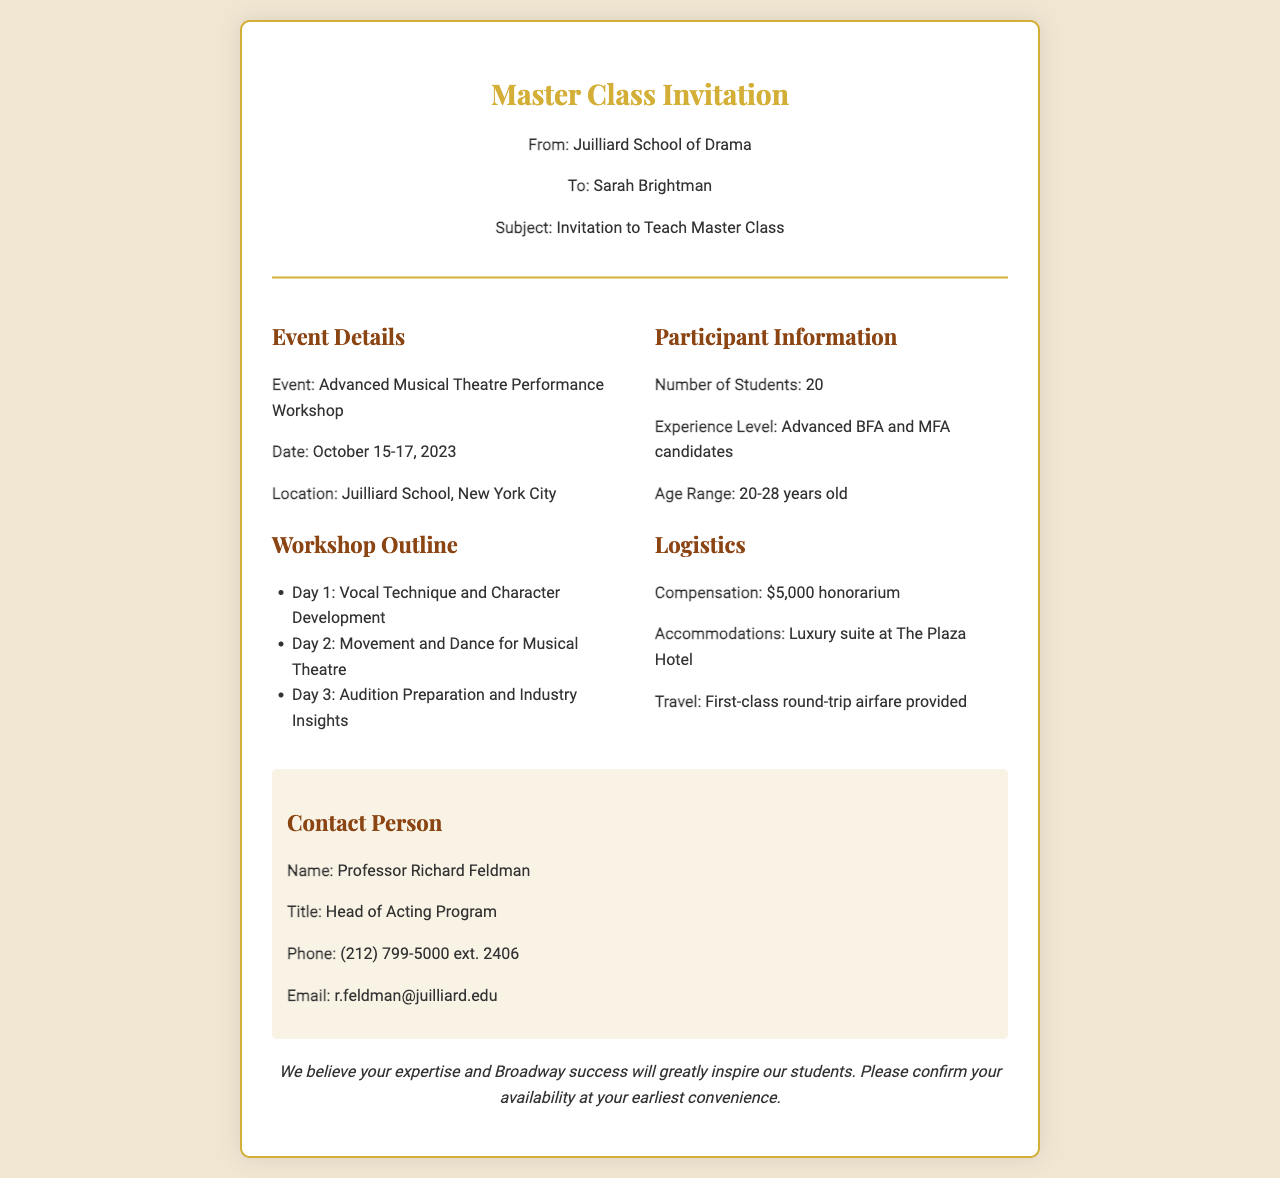What is the name of the workshop? The name of the workshop is stated in the event details section of the document.
Answer: Advanced Musical Theatre Performance Workshop What are the dates of the master class? The dates are specified under the event details, showing when the workshop will take place.
Answer: October 15-17, 2023 How many students will participate? The number of students is indicated in the participant information section.
Answer: 20 Who is the contact person for the master class? The contact person is mentioned in the contact info section, identifying who to reach for more details.
Answer: Professor Richard Feldman What is the compensation amount mentioned for teaching? The compensation is outlined in the logistics section of the document.
Answer: $5,000 honorarium What type of accommodations are provided? The specific type of accommodations is listed under the logistics heading.
Answer: Luxury suite at The Plaza Hotel Which day focuses on Movement and Dance for Musical Theatre? The workshop outline clearly states each day's focus, allowing for reasoning about which topic matches.
Answer: Day 2 What is the age range of the participants? The age range is detailed in the participant information section, providing a demographic overview.
Answer: 20-28 years old 